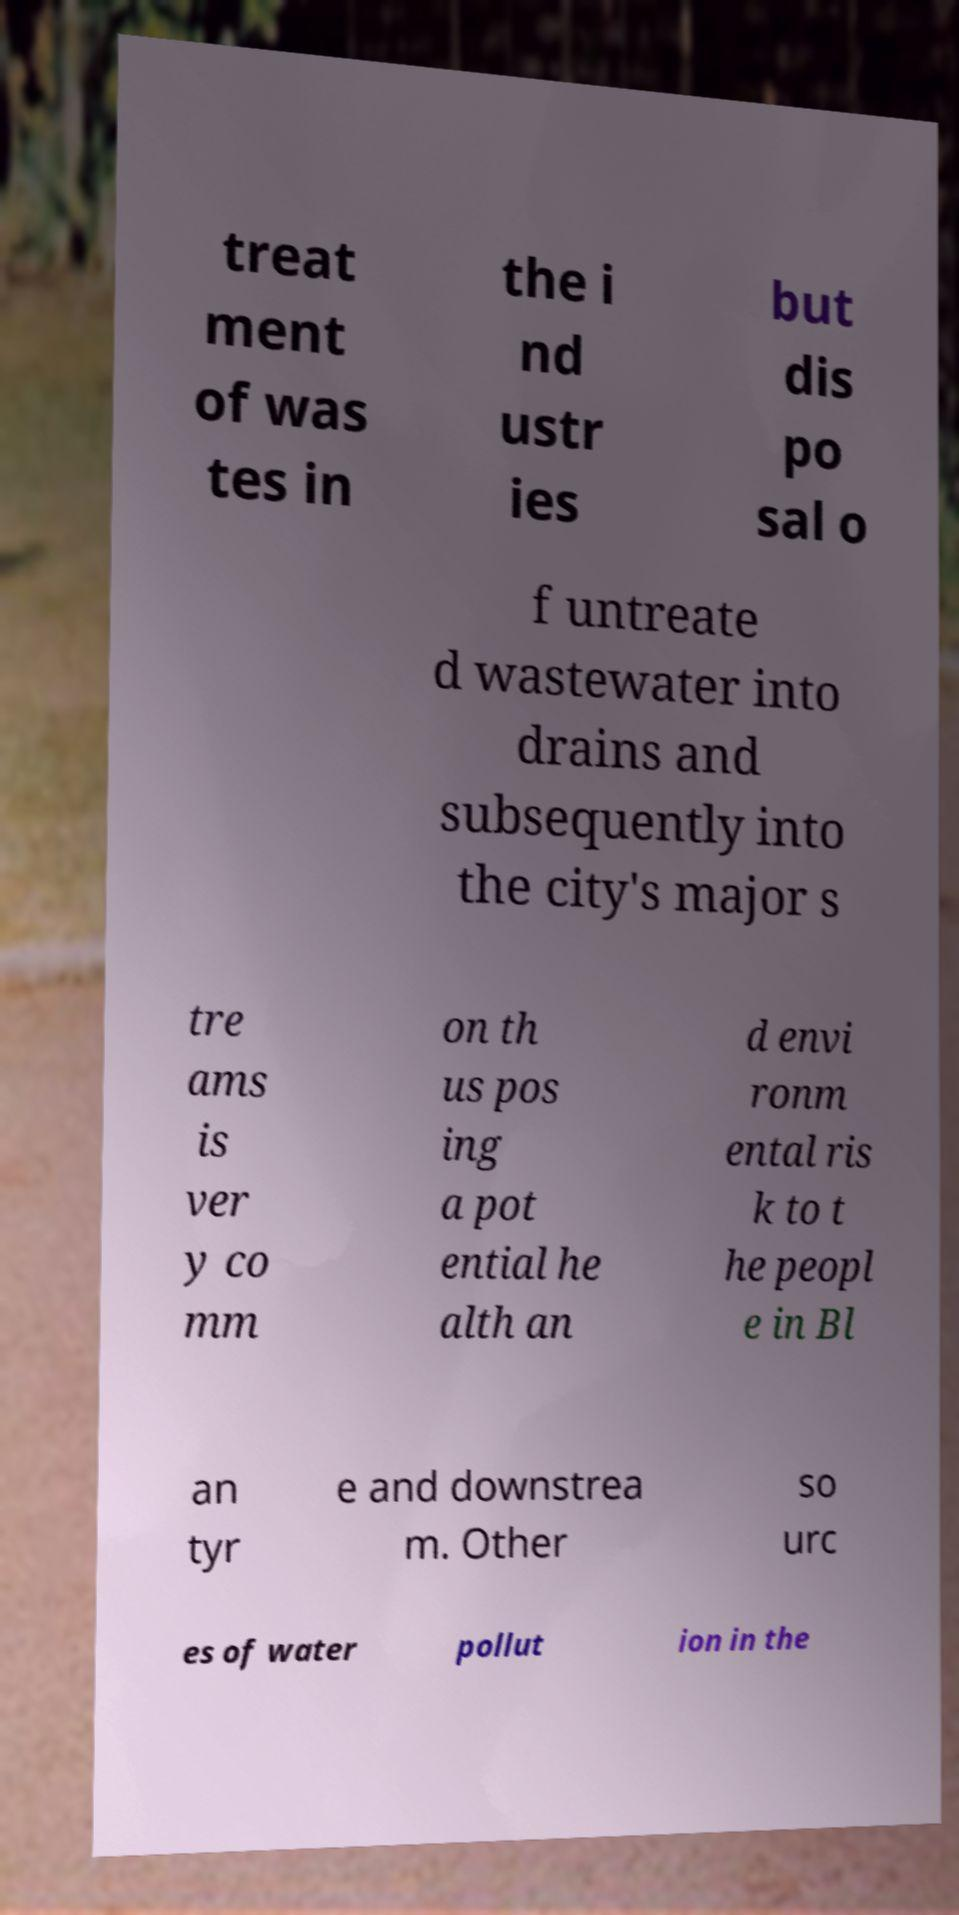There's text embedded in this image that I need extracted. Can you transcribe it verbatim? treat ment of was tes in the i nd ustr ies but dis po sal o f untreate d wastewater into drains and subsequently into the city's major s tre ams is ver y co mm on th us pos ing a pot ential he alth an d envi ronm ental ris k to t he peopl e in Bl an tyr e and downstrea m. Other so urc es of water pollut ion in the 